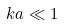Convert formula to latex. <formula><loc_0><loc_0><loc_500><loc_500>k a \ll 1</formula> 